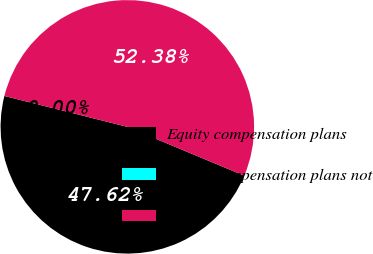Convert chart. <chart><loc_0><loc_0><loc_500><loc_500><pie_chart><fcel>Equity compensation plans<fcel>Equity compensation plans not<fcel>Total<nl><fcel>47.62%<fcel>0.0%<fcel>52.38%<nl></chart> 